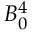Convert formula to latex. <formula><loc_0><loc_0><loc_500><loc_500>B _ { 0 } ^ { 4 }</formula> 